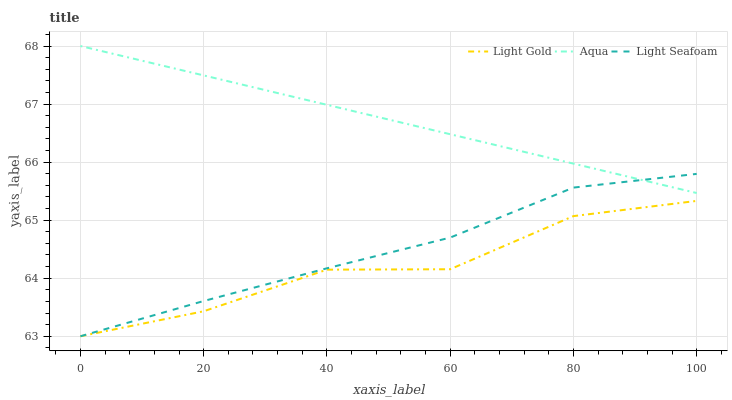Does Light Gold have the minimum area under the curve?
Answer yes or no. Yes. Does Aqua have the maximum area under the curve?
Answer yes or no. Yes. Does Light Seafoam have the minimum area under the curve?
Answer yes or no. No. Does Light Seafoam have the maximum area under the curve?
Answer yes or no. No. Is Aqua the smoothest?
Answer yes or no. Yes. Is Light Gold the roughest?
Answer yes or no. Yes. Is Light Seafoam the smoothest?
Answer yes or no. No. Is Light Seafoam the roughest?
Answer yes or no. No. Does Light Seafoam have the highest value?
Answer yes or no. No. Is Light Gold less than Aqua?
Answer yes or no. Yes. Is Aqua greater than Light Gold?
Answer yes or no. Yes. Does Light Gold intersect Aqua?
Answer yes or no. No. 